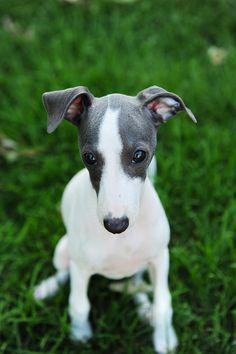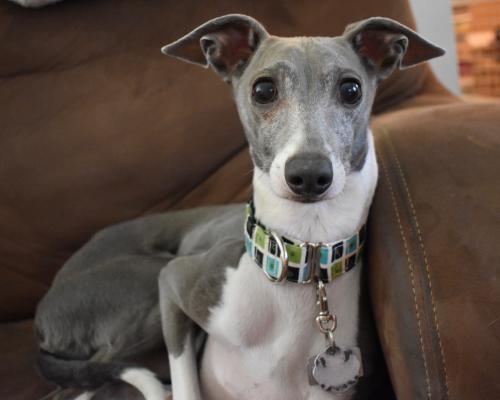The first image is the image on the left, the second image is the image on the right. Considering the images on both sides, is "One dog has a collar on." valid? Answer yes or no. Yes. 